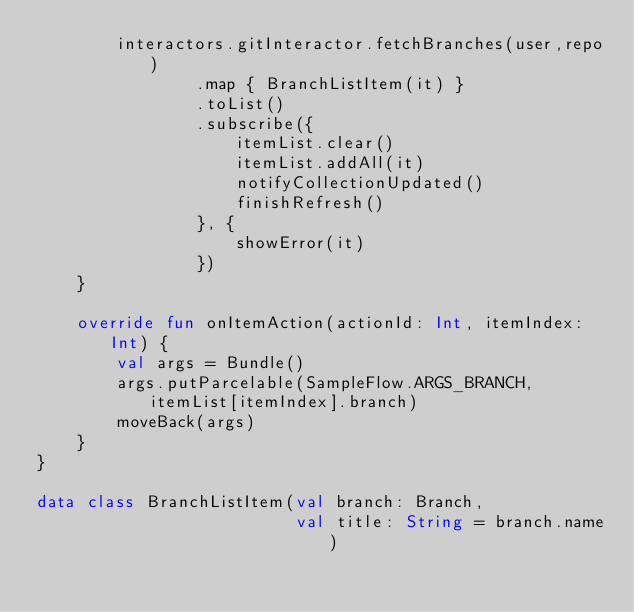Convert code to text. <code><loc_0><loc_0><loc_500><loc_500><_Kotlin_>        interactors.gitInteractor.fetchBranches(user,repo)
                .map { BranchListItem(it) }
                .toList()
                .subscribe({
                    itemList.clear()
                    itemList.addAll(it)
                    notifyCollectionUpdated()
                    finishRefresh()
                }, {
                    showError(it)
                })
    }

    override fun onItemAction(actionId: Int, itemIndex: Int) {
        val args = Bundle()
        args.putParcelable(SampleFlow.ARGS_BRANCH,itemList[itemIndex].branch)
        moveBack(args)
    }
}

data class BranchListItem(val branch: Branch,
                          val title: String = branch.name)
</code> 